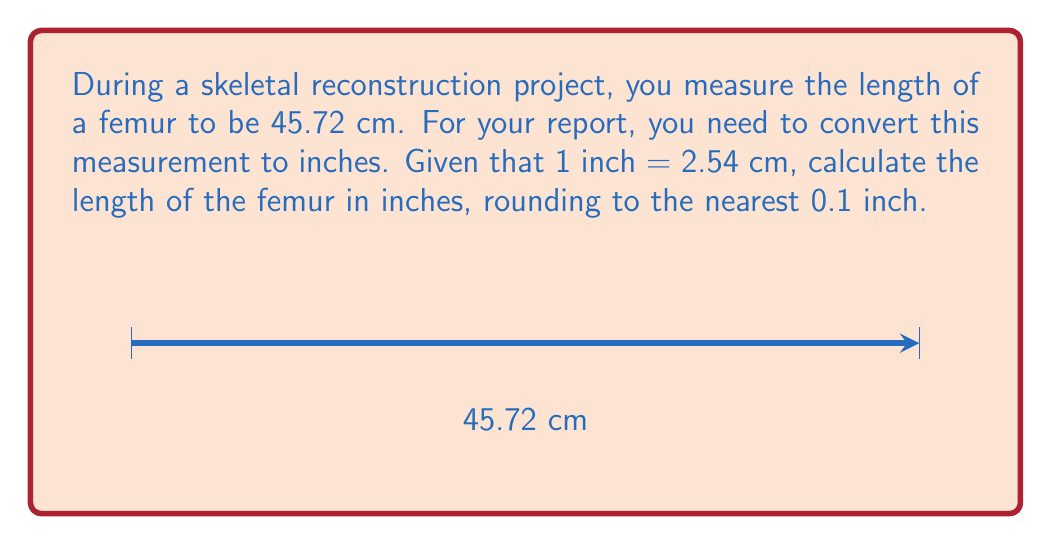Teach me how to tackle this problem. To convert the femur length from centimeters to inches, we'll use the given conversion factor: 1 inch = 2.54 cm.

Step 1: Set up the conversion ratio.
$$\frac{45.72 \text{ cm}}{x \text{ inches}} = \frac{2.54 \text{ cm}}{1 \text{ inch}}$$

Step 2: Cross multiply to solve for $x$.
$$(45.72)(1) = (2.54)(x)$$

Step 3: Solve the equation.
$$x = \frac{45.72}{2.54} = 18 \text{ inches}$$

Step 4: Round to the nearest 0.1 inch.
The result is already a whole number, so no rounding is necessary.

Therefore, 45.72 cm is equivalent to 18.0 inches.
Answer: 18.0 inches 